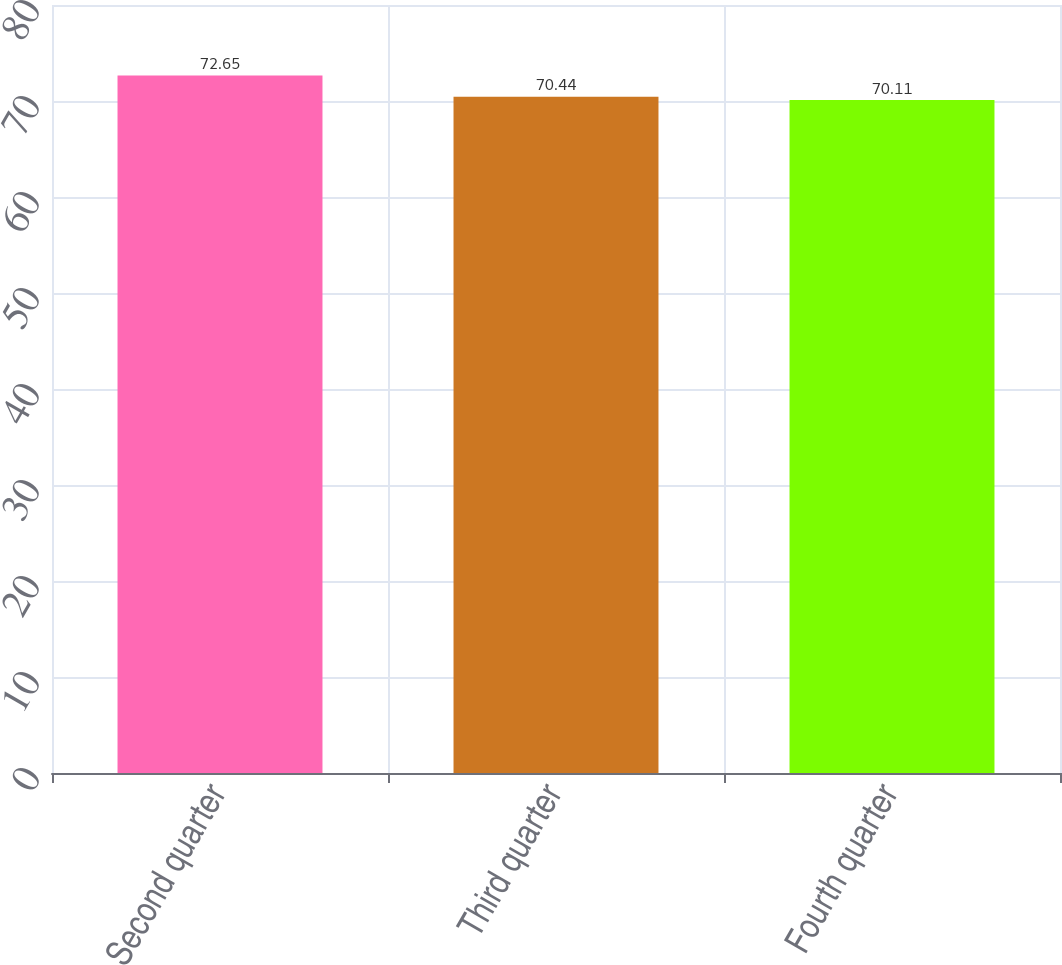Convert chart to OTSL. <chart><loc_0><loc_0><loc_500><loc_500><bar_chart><fcel>Second quarter<fcel>Third quarter<fcel>Fourth quarter<nl><fcel>72.65<fcel>70.44<fcel>70.11<nl></chart> 